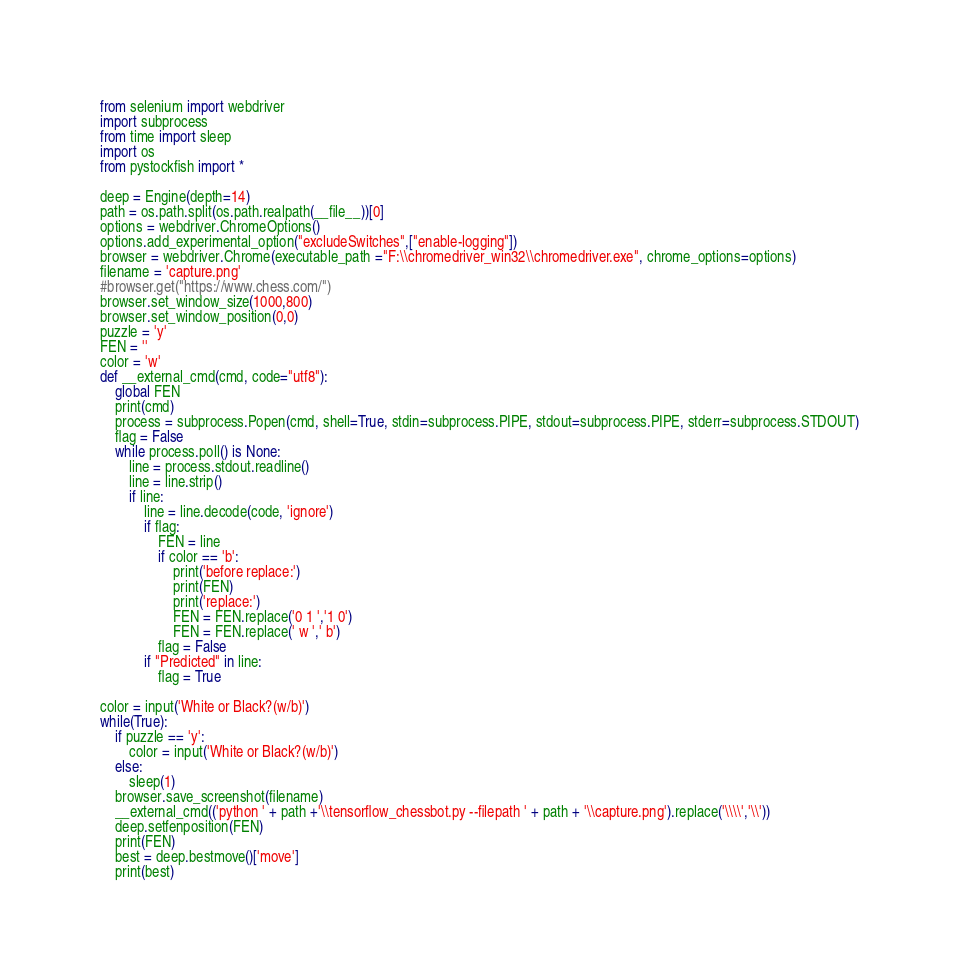<code> <loc_0><loc_0><loc_500><loc_500><_Python_>from selenium import webdriver
import subprocess
from time import sleep
import os
from pystockfish import *

deep = Engine(depth=14)
path = os.path.split(os.path.realpath(__file__))[0]
options = webdriver.ChromeOptions()
options.add_experimental_option("excludeSwitches",["enable-logging"])
browser = webdriver.Chrome(executable_path ="F:\\chromedriver_win32\\chromedriver.exe", chrome_options=options)
filename = 'capture.png'
#browser.get("https://www.chess.com/")
browser.set_window_size(1000,800)
browser.set_window_position(0,0)
puzzle = 'y'
FEN = ''
color = 'w'
def __external_cmd(cmd, code="utf8"):
    global FEN
    print(cmd)
    process = subprocess.Popen(cmd, shell=True, stdin=subprocess.PIPE, stdout=subprocess.PIPE, stderr=subprocess.STDOUT)
    flag = False
    while process.poll() is None:
        line = process.stdout.readline()
        line = line.strip()
        if line:
            line = line.decode(code, 'ignore')
            if flag:
                FEN = line
                if color == 'b':
                    print('before replace:')
                    print(FEN)
                    print('replace:')
                    FEN = FEN.replace('0 1 ','1 0')
                    FEN = FEN.replace(' w ',' b')
                flag = False
            if "Predicted" in line:
                flag = True

color = input('White or Black?(w/b)')
while(True):
    if puzzle == 'y':
        color = input('White or Black?(w/b)')
    else:
        sleep(1)
    browser.save_screenshot(filename)
    __external_cmd(('python ' + path +'\\tensorflow_chessbot.py --filepath ' + path + '\\capture.png').replace('\\\\','\\'))
    deep.setfenposition(FEN)
    print(FEN)
    best = deep.bestmove()['move']
    print(best)</code> 